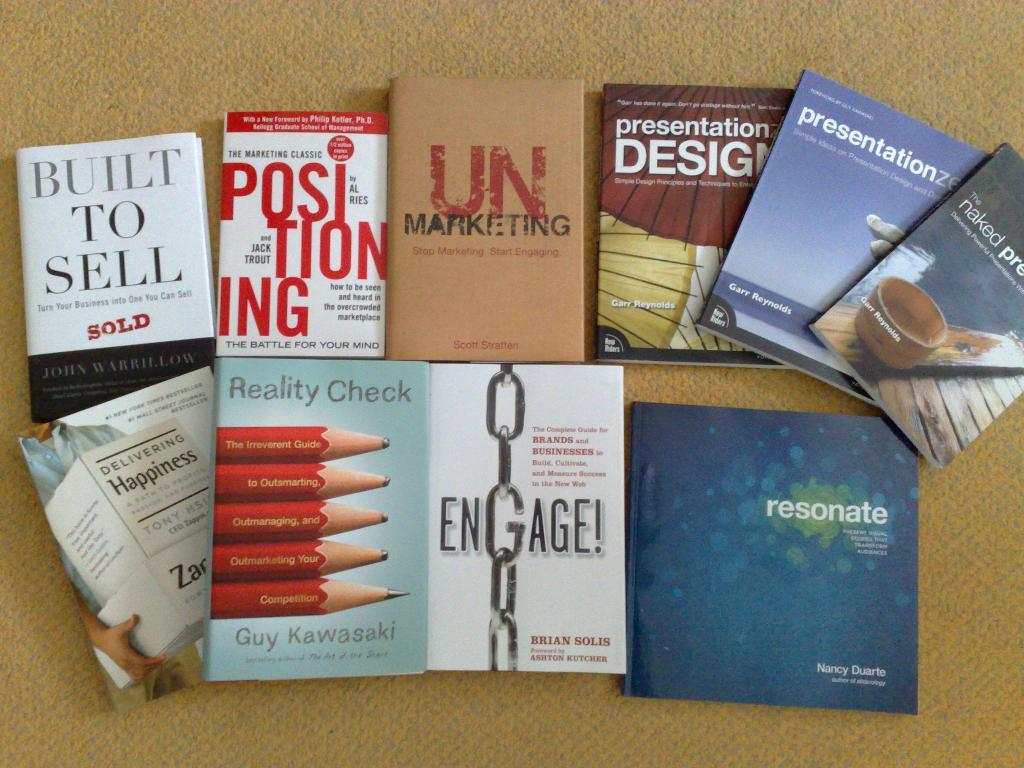Provide a one-sentence caption for the provided image. brown background with ten books on it with titles such as unmarketing and built to sell. 